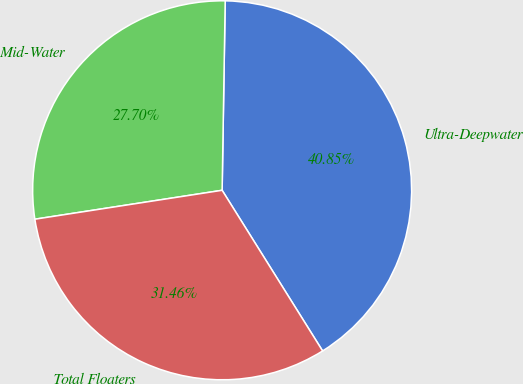Convert chart. <chart><loc_0><loc_0><loc_500><loc_500><pie_chart><fcel>Ultra-Deepwater<fcel>Mid-Water<fcel>Total Floaters<nl><fcel>40.85%<fcel>27.7%<fcel>31.46%<nl></chart> 